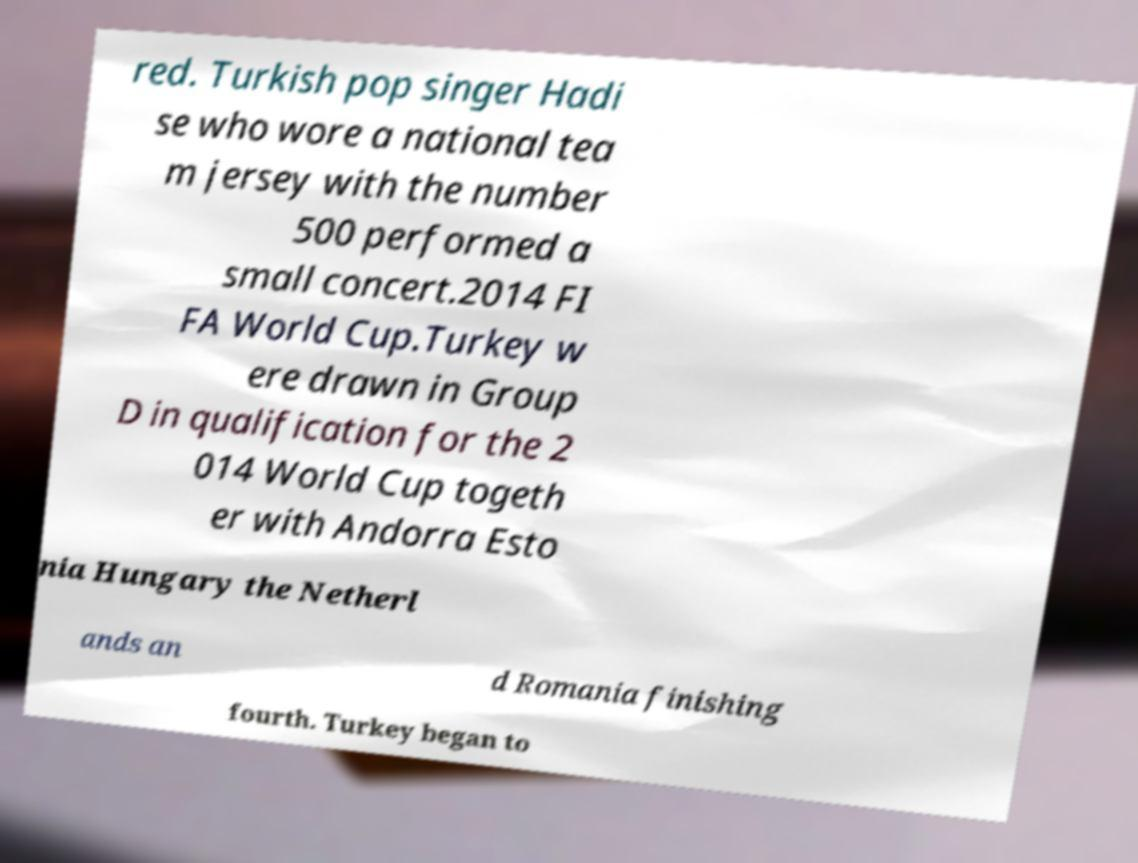There's text embedded in this image that I need extracted. Can you transcribe it verbatim? red. Turkish pop singer Hadi se who wore a national tea m jersey with the number 500 performed a small concert.2014 FI FA World Cup.Turkey w ere drawn in Group D in qualification for the 2 014 World Cup togeth er with Andorra Esto nia Hungary the Netherl ands an d Romania finishing fourth. Turkey began to 